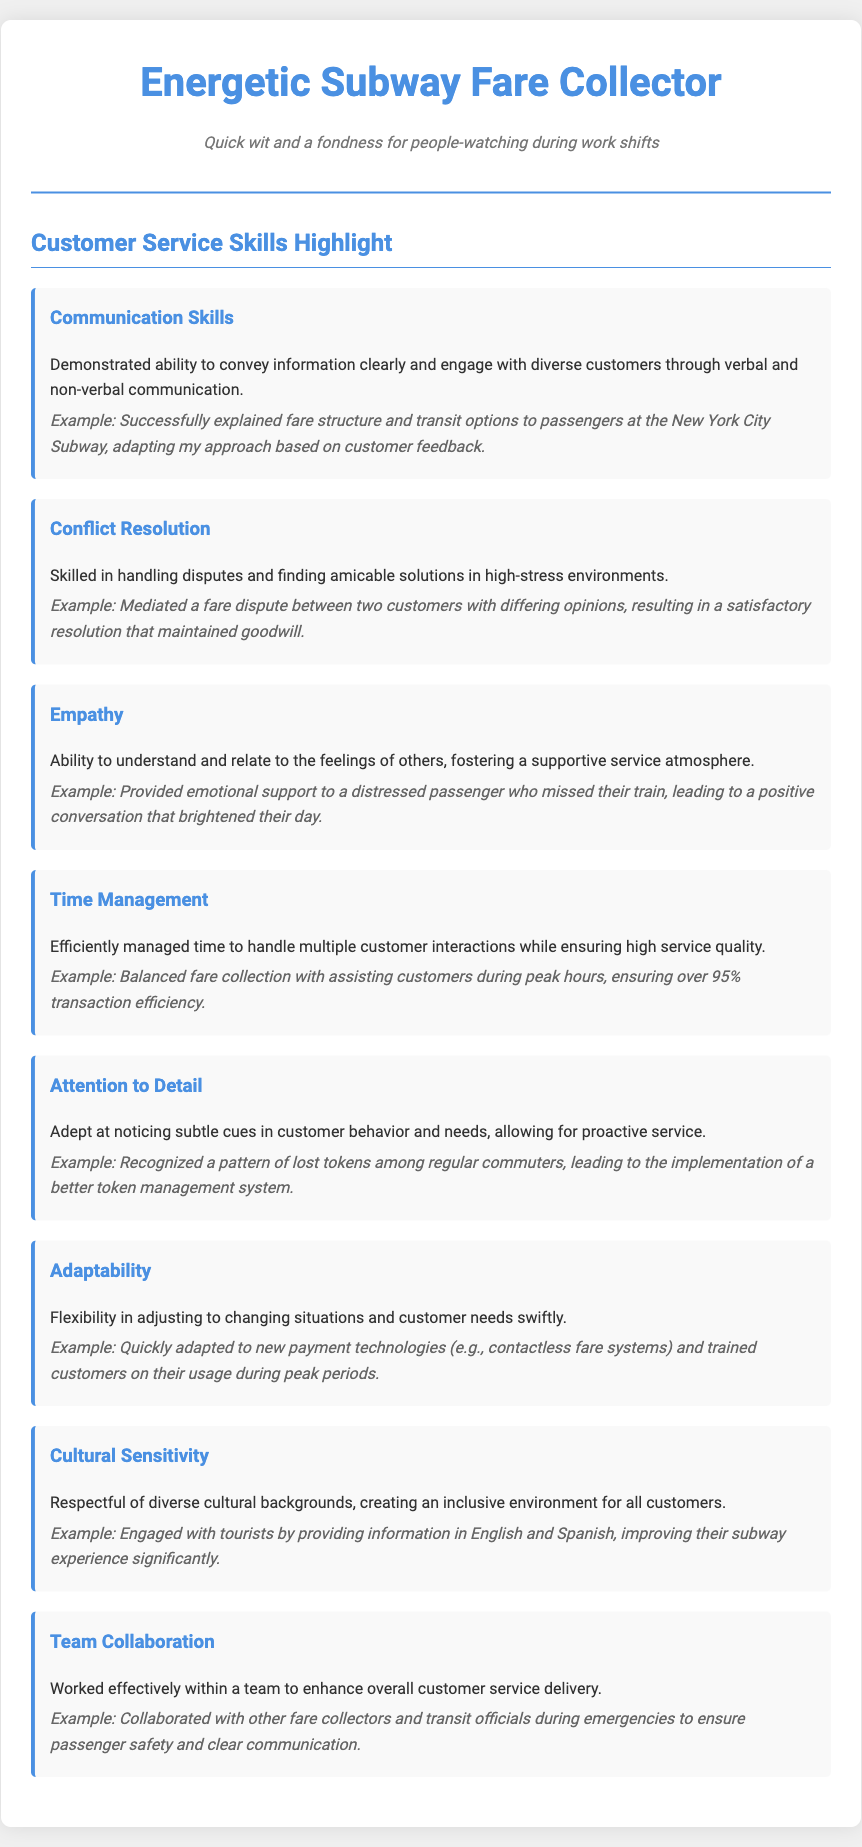What is the title of the document? The title at the top of the document states the role of the individual, which is "Energetic Subway Fare Collector."
Answer: Energetic Subway Fare Collector How many main customer service skills are highlighted? The document lists a total of eight customer service skills.
Answer: Eight What skill is associated with resolving disputes? The skill specifically mentioned for resolving disputes is "Conflict Resolution."
Answer: Conflict Resolution Which example demonstrates empathy? The example showcasing empathy involves providing emotional support to a distressed passenger.
Answer: Provided emotional support to a distressed passenger who missed their train What percentage of transaction efficiency is mentioned in relation to time management? The document indicates that over 95% transaction efficiency was achieved while balancing fare collection.
Answer: Over 95% What skill involves interacting with customers from diverse backgrounds? The skill that involves interacting with diverse backgrounds is "Cultural Sensitivity."
Answer: Cultural Sensitivity Which skill includes adapting to new payment technologies? The skill related to adapting to new payment technologies is "Adaptability."
Answer: Adaptability What is a key characteristic of the communication skills mentioned? The communication skills are characterized by the ability to convey information clearly and engage with diverse customers.
Answer: Convey information clearly and engage with diverse customers How does the document suggest enhancing customer service delivery? The document suggests enhancing customer service delivery through "Team Collaboration."
Answer: Team Collaboration 